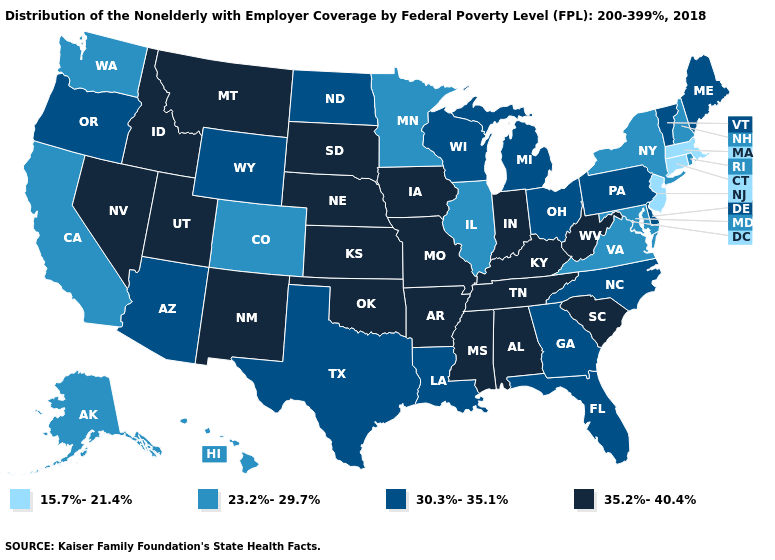What is the value of New Jersey?
Concise answer only. 15.7%-21.4%. Which states have the lowest value in the USA?
Give a very brief answer. Connecticut, Massachusetts, New Jersey. What is the value of Oregon?
Answer briefly. 30.3%-35.1%. Which states have the lowest value in the USA?
Quick response, please. Connecticut, Massachusetts, New Jersey. Does Kentucky have the same value as Rhode Island?
Concise answer only. No. Which states have the lowest value in the USA?
Write a very short answer. Connecticut, Massachusetts, New Jersey. Among the states that border New Jersey , does Delaware have the highest value?
Give a very brief answer. Yes. What is the highest value in the Northeast ?
Short answer required. 30.3%-35.1%. Name the states that have a value in the range 35.2%-40.4%?
Keep it brief. Alabama, Arkansas, Idaho, Indiana, Iowa, Kansas, Kentucky, Mississippi, Missouri, Montana, Nebraska, Nevada, New Mexico, Oklahoma, South Carolina, South Dakota, Tennessee, Utah, West Virginia. Among the states that border Tennessee , does Virginia have the lowest value?
Be succinct. Yes. Does Wyoming have the same value as Washington?
Short answer required. No. Does Nebraska have the lowest value in the USA?
Short answer required. No. Name the states that have a value in the range 30.3%-35.1%?
Write a very short answer. Arizona, Delaware, Florida, Georgia, Louisiana, Maine, Michigan, North Carolina, North Dakota, Ohio, Oregon, Pennsylvania, Texas, Vermont, Wisconsin, Wyoming. Name the states that have a value in the range 23.2%-29.7%?
Concise answer only. Alaska, California, Colorado, Hawaii, Illinois, Maryland, Minnesota, New Hampshire, New York, Rhode Island, Virginia, Washington. Which states hav the highest value in the South?
Write a very short answer. Alabama, Arkansas, Kentucky, Mississippi, Oklahoma, South Carolina, Tennessee, West Virginia. 